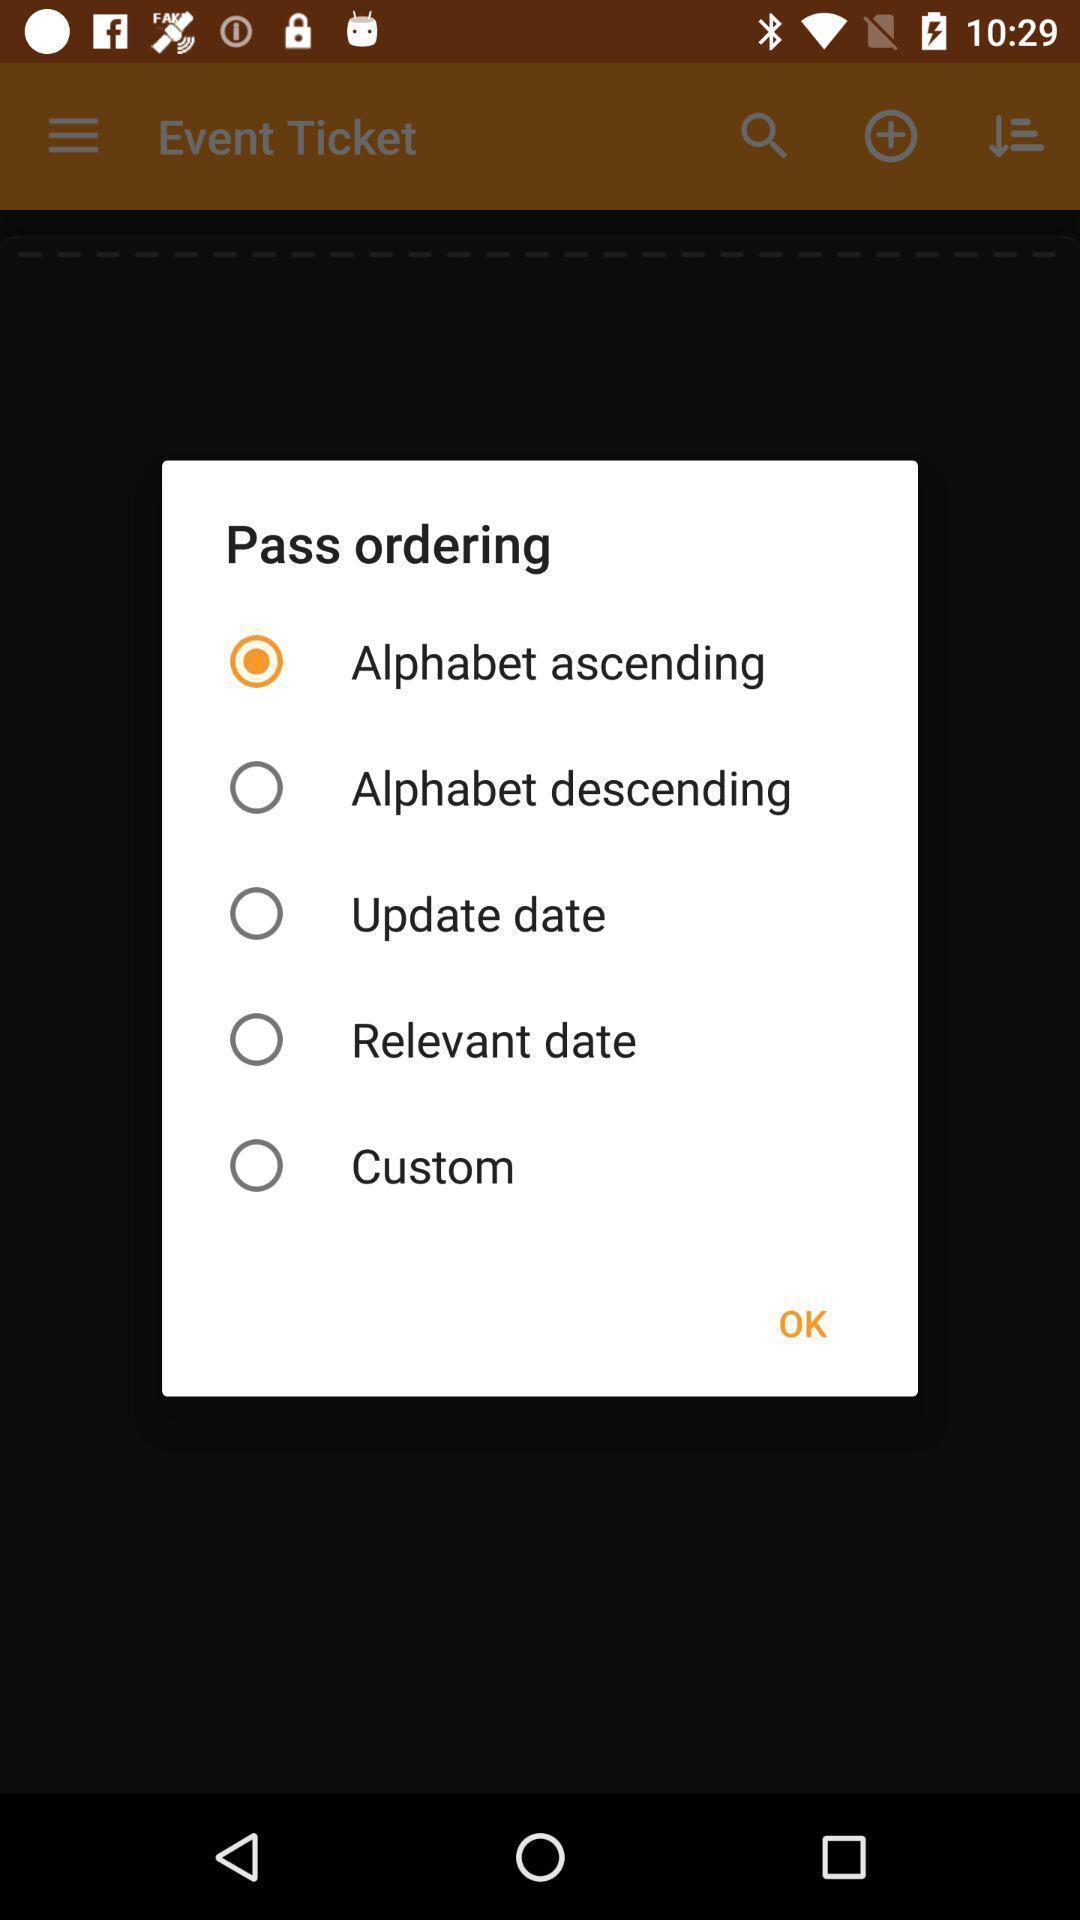Give me a summary of this screen capture. Popup of alphabet settings in application. 